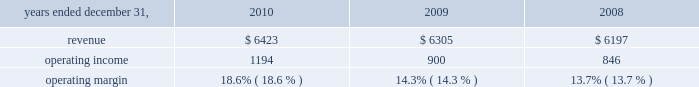Considered to be the primary beneficiary of either entity and have therefore deconsolidated both entities .
At december 31 , 2010 , we held a 36% ( 36 % ) interest in juniperus which is accounted for using the equity method of accounting .
Our potential loss at december 31 , 2010 is limited to our investment of $ 73 million in juniperus , which is recorded in investments in the consolidated statements of financial position .
We have not provided any financing to juniperus other than previously contractually required amounts .
Juniperus and jchl had combined assets and liabilities of $ 121 million and $ 22 million , respectively , at december 31 , 2008 .
For the year ended december 31 , 2009 , we recognized $ 36 million of pretax income from juniperus and jchl .
We recognized $ 16 million of after-tax income , after allocating the appropriate share of net income to the non-controlling interests .
We previously owned an 85% ( 85 % ) economic equity interest in globe re limited ( 2018 2018globe re 2019 2019 ) , a vie , which provided reinsurance coverage for a defined portfolio of property catastrophe reinsurance contracts underwritten by a third party for a limited period which ended june 1 , 2009 .
We consolidated globe re as we were deemed to be the primary beneficiary .
In connection with the winding up of its operations , globe re repaid its $ 100 million of short-term debt and our equity investment from available cash in 2009 .
We recognized $ 2 million of after-tax income from globe re in 2009 , taking into account the share of net income attributable to non-controlling interests .
Globe re was fully liquidated in the third quarter of 2009 .
Review by segment general we serve clients through the following segments : 2022 risk solutions ( formerly risk and insurance brokerage services ) acts as an advisor and insurance and reinsurance broker , helping clients manage their risks , via consultation , as well as negotiation and placement of insurance risk with insurance carriers through our global distribution network .
2022 hr solutions ( formerly consulting ) partners with organizations to solve their most complex benefits , talent and related financial challenges , and improve business performance by designing , implementing , communicating and administering a wide range of human capital , retirement , investment management , health care , compensation and talent management strategies .
Risk solutions .
The demand for property and casualty insurance generally rises as the overall level of economic activity increases and generally falls as such activity decreases , affecting both the commissions and fees generated by our brokerage business .
The economic activity that impacts property and casualty insurance is described as exposure units , and is most closely correlated with employment levels , corporate revenue and asset values .
During 2010 we continued to see a 2018 2018soft market 2019 2019 , which began in 2007 , in our retail brokerage product line .
In a soft market , premium rates flatten or decrease , along with commission revenues , due to increased competition for market share among insurance carriers or increased underwriting capacity .
Changes in premiums have a direct and potentially material impact on the insurance brokerage industry , as commission revenues are generally based on a percentage of the .
At december 2008 what was the combined debt to asset ration of both 5] : juniperus and jchl? 
Computations: (22 / 121)
Answer: 0.18182. 